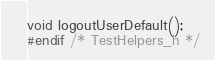Convert code to text. <code><loc_0><loc_0><loc_500><loc_500><_C_>void logoutUserDefault();
#endif /* TestHelpers_h */
</code> 